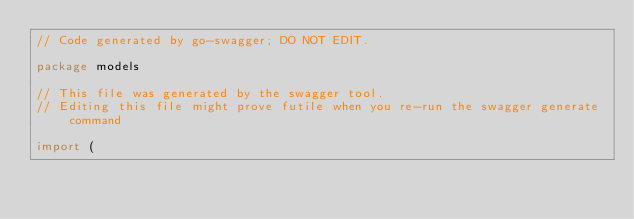<code> <loc_0><loc_0><loc_500><loc_500><_Go_>// Code generated by go-swagger; DO NOT EDIT.

package models

// This file was generated by the swagger tool.
// Editing this file might prove futile when you re-run the swagger generate command

import (</code> 